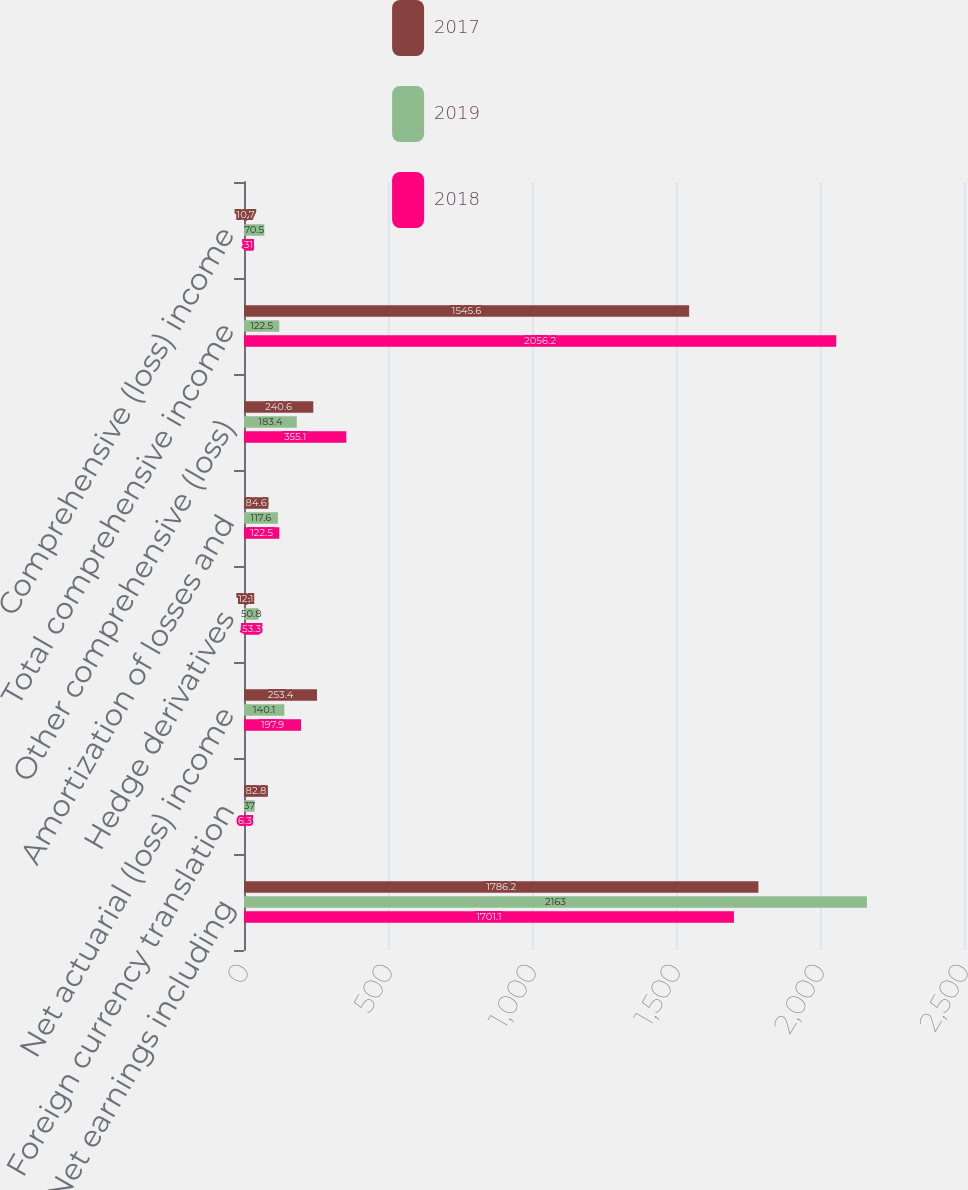Convert chart. <chart><loc_0><loc_0><loc_500><loc_500><stacked_bar_chart><ecel><fcel>Net earnings including<fcel>Foreign currency translation<fcel>Net actuarial (loss) income<fcel>Hedge derivatives<fcel>Amortization of losses and<fcel>Other comprehensive (loss)<fcel>Total comprehensive income<fcel>Comprehensive (loss) income<nl><fcel>2017<fcel>1786.2<fcel>82.8<fcel>253.4<fcel>12.1<fcel>84.6<fcel>240.6<fcel>1545.6<fcel>10.7<nl><fcel>2019<fcel>2163<fcel>37<fcel>140.1<fcel>50.8<fcel>117.6<fcel>183.4<fcel>122.5<fcel>70.5<nl><fcel>2018<fcel>1701.1<fcel>6.3<fcel>197.9<fcel>53.3<fcel>122.5<fcel>355.1<fcel>2056.2<fcel>31<nl></chart> 